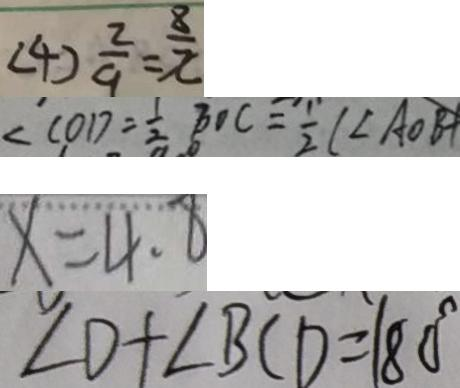Convert formula to latex. <formula><loc_0><loc_0><loc_500><loc_500>( 4 ) \frac { 2 } { 9 } = \frac { 8 } { x } 
 \angle C O D = \frac { 1 } { 2 } B O C = \frac { 1 } { 2 } ( \angle A O B + 
 x = 4 . 8 
 \angle D + \angle B C D = 1 8 0 ^ { \circ }</formula> 